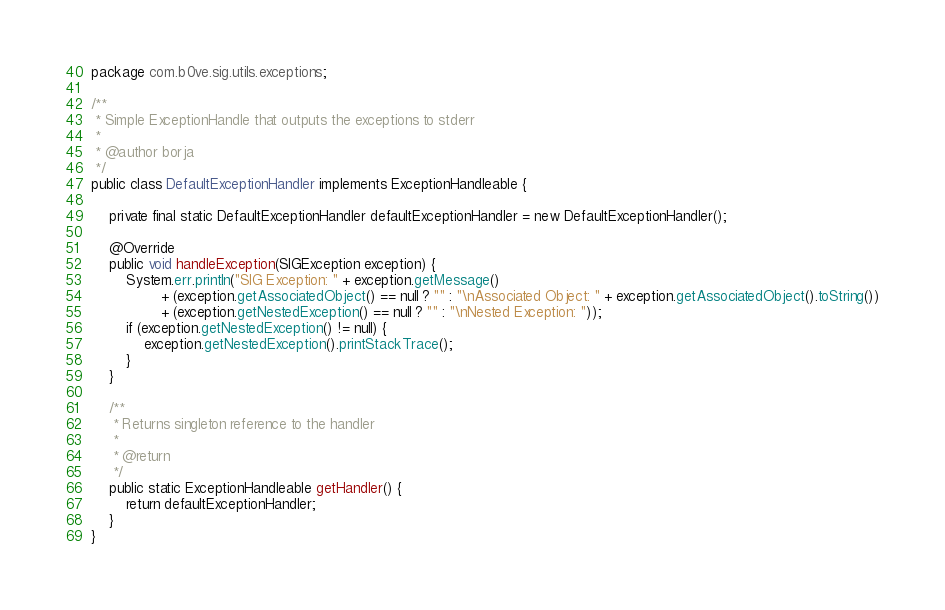<code> <loc_0><loc_0><loc_500><loc_500><_Java_>package com.b0ve.sig.utils.exceptions;

/**
 * Simple ExceptionHandle that outputs the exceptions to stderr
 *
 * @author borja
 */
public class DefaultExceptionHandler implements ExceptionHandleable {

    private final static DefaultExceptionHandler defaultExceptionHandler = new DefaultExceptionHandler();

    @Override
    public void handleException(SIGException exception) {
        System.err.println("SIG Exception: " + exception.getMessage()
                + (exception.getAssociatedObject() == null ? "" : "\nAssociated Object: " + exception.getAssociatedObject().toString())
                + (exception.getNestedException() == null ? "" : "\nNested Exception: "));
        if (exception.getNestedException() != null) {
            exception.getNestedException().printStackTrace();
        }
    }

    /**
     * Returns singleton reference to the handler
     *
     * @return
     */
    public static ExceptionHandleable getHandler() {
        return defaultExceptionHandler;
    }
}
</code> 